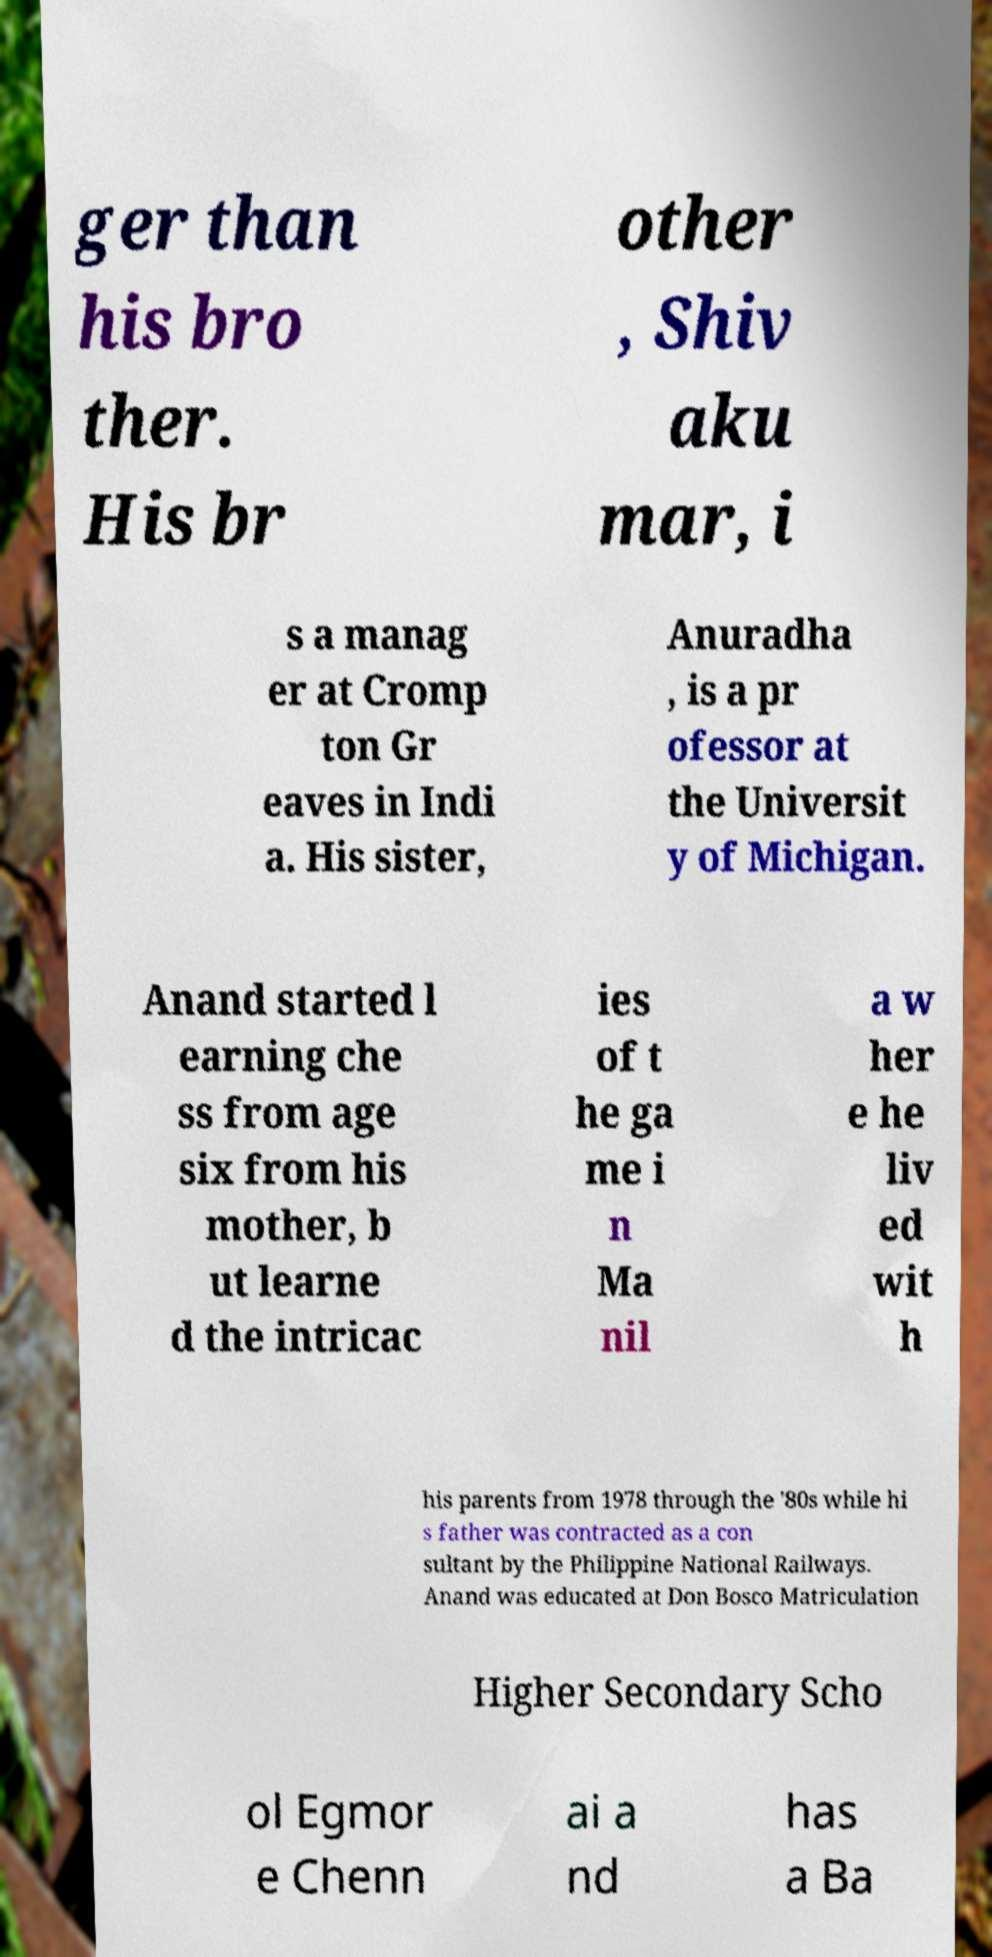What messages or text are displayed in this image? I need them in a readable, typed format. ger than his bro ther. His br other , Shiv aku mar, i s a manag er at Cromp ton Gr eaves in Indi a. His sister, Anuradha , is a pr ofessor at the Universit y of Michigan. Anand started l earning che ss from age six from his mother, b ut learne d the intricac ies of t he ga me i n Ma nil a w her e he liv ed wit h his parents from 1978 through the '80s while hi s father was contracted as a con sultant by the Philippine National Railways. Anand was educated at Don Bosco Matriculation Higher Secondary Scho ol Egmor e Chenn ai a nd has a Ba 